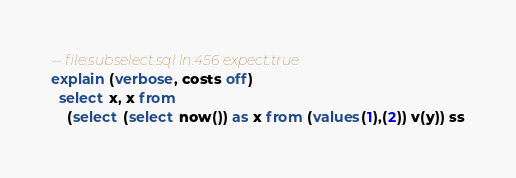Convert code to text. <code><loc_0><loc_0><loc_500><loc_500><_SQL_>-- file:subselect.sql ln:456 expect:true
explain (verbose, costs off)
  select x, x from
    (select (select now()) as x from (values(1),(2)) v(y)) ss
</code> 